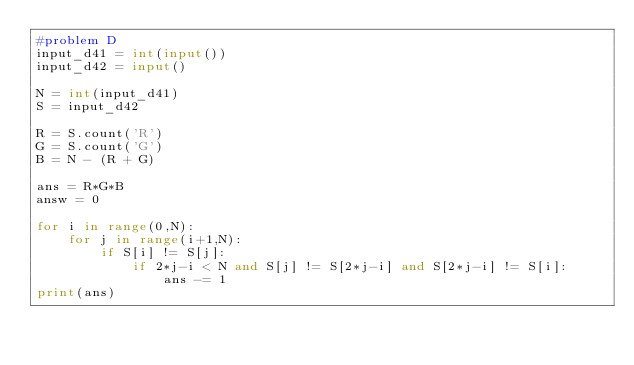<code> <loc_0><loc_0><loc_500><loc_500><_Python_>#problem D
input_d41 = int(input())
input_d42 = input()

N = int(input_d41)
S = input_d42

R = S.count('R')
G = S.count('G')
B = N - (R + G)

ans = R*G*B
answ = 0

for i in range(0,N):
    for j in range(i+1,N):
        if S[i] != S[j]:
            if 2*j-i < N and S[j] != S[2*j-i] and S[2*j-i] != S[i]:
                ans -= 1
print(ans)</code> 